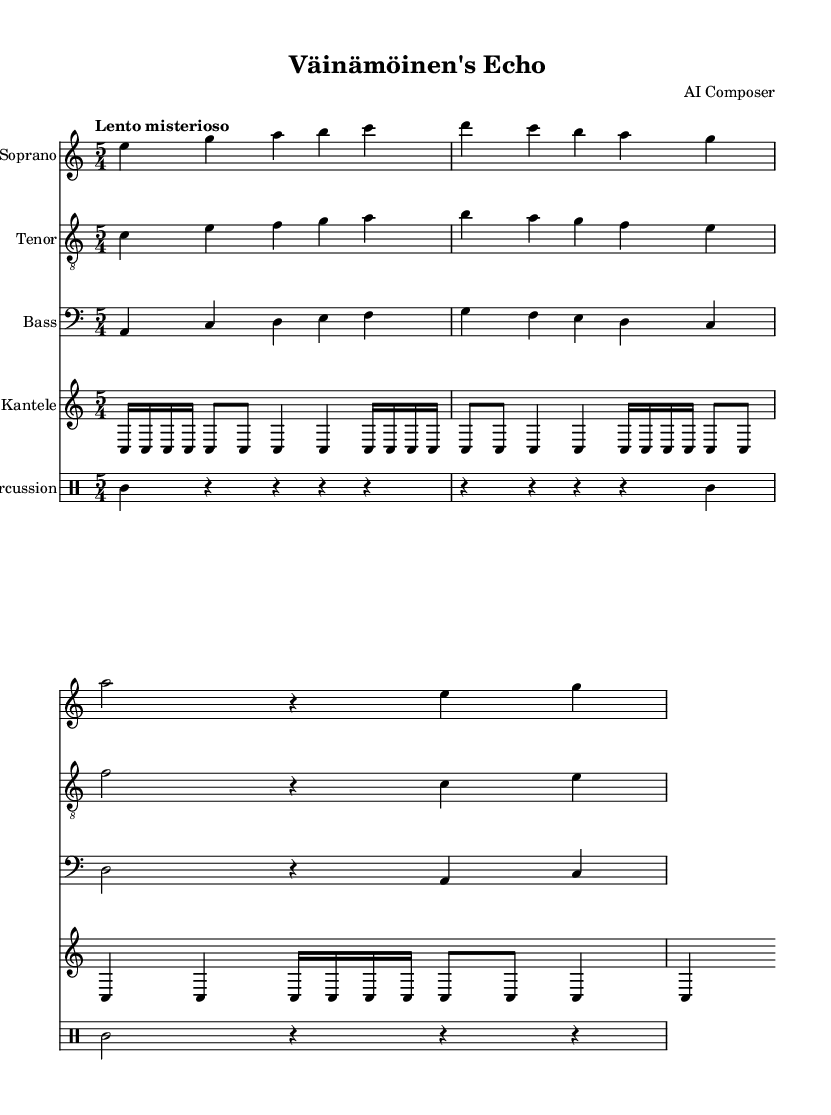What is the key signature of this music? The key signature is A minor, which has no sharps or flats and indicates the relative minor of C major. This can be found at the beginning of the score where the key signature is indicated.
Answer: A minor What is the time signature of this piece? The time signature is five-four, as seen at the beginning of the score. This means there are five beats in each measure and the quarter note gets one beat.
Answer: Five-four What is the tempo marking of the music? The tempo marking is "Lento misterioso," which indicates a slow and mysterious tempo. This is usually stated at the beginning of the score, guiding the performer on how to interpret the pace of the music.
Answer: Lento misterioso How many measures are there in the soprano music? The soprano music consists of four measures, which can be counted by looking at the grouping of notes and bar lines in the staff.
Answer: Four What instrument is featured alongside the voice parts in this score? The featured instrument alongside the voice parts is the kantele, which is indicated by the staff labeled "Kantele." This traditional Finnish instrument complements the vocal lines.
Answer: Kantele What is the overall theme of the lyrics in this opera? The overall theme of the lyrics is evoking imagery from Finnish folklore, specifically related to ancient forests and the spirit of Kalevala, which reflects the cultural roots and history of Finland. This theme is conveyed through the lyrics found in the voice parts.
Answer: Finnish folklore 